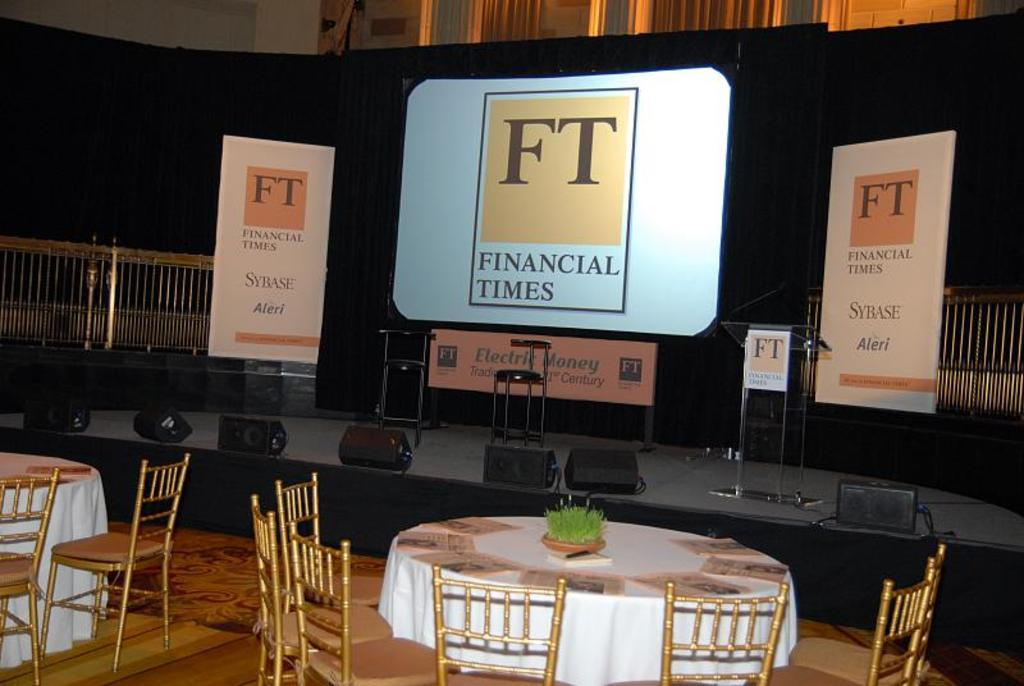Provide a one-sentence caption for the provided image. a presentation board that says 'financial times' on it. 